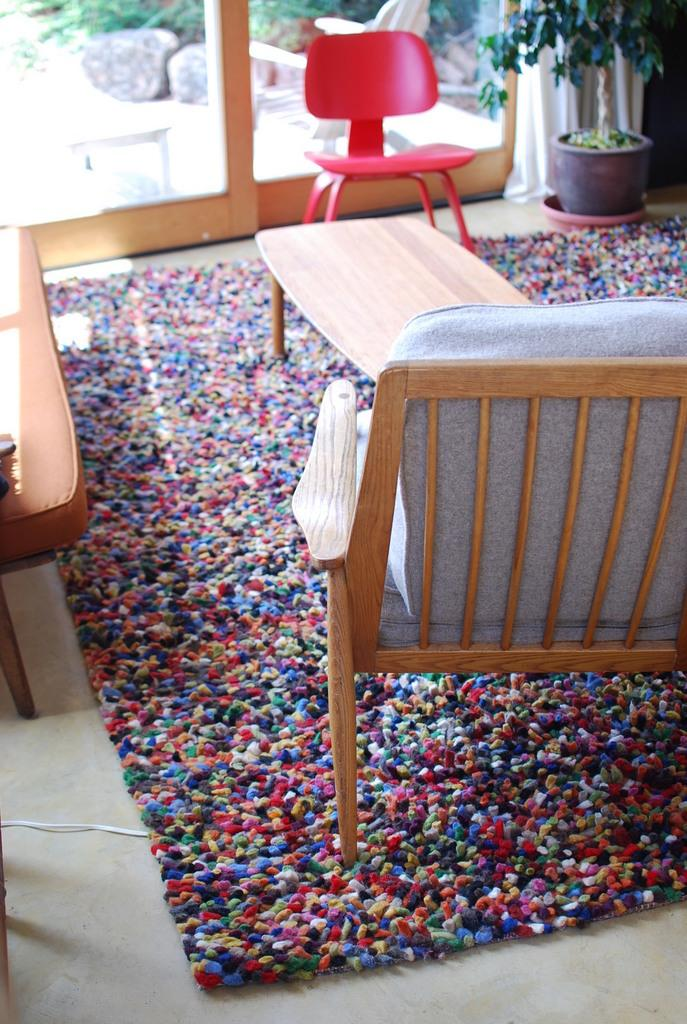What type of space is depicted in the image? The image shows an inside view of a room. What furniture can be seen in the room? There are chairs and a table in the room. What type of flooring is present in the room? The room has a carpet. Where is the plant located in the image? There is a plant in the top right corner of the image. What type of window treatment is present in the room? There are curtains in the image. What is the opinion of the pocket on the sheet in the image? There is no pocket or sheet present in the image, so it is not possible to determine any opinions. 